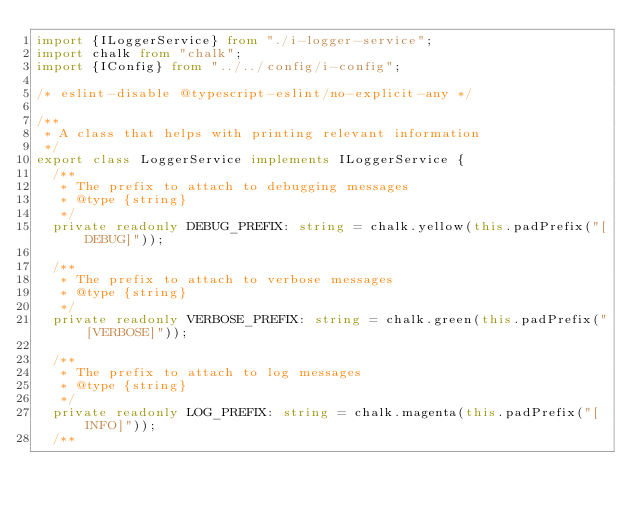<code> <loc_0><loc_0><loc_500><loc_500><_TypeScript_>import {ILoggerService} from "./i-logger-service";
import chalk from "chalk";
import {IConfig} from "../../config/i-config";

/* eslint-disable @typescript-eslint/no-explicit-any */

/**
 * A class that helps with printing relevant information
 */
export class LoggerService implements ILoggerService {
	/**
	 * The prefix to attach to debugging messages
	 * @type {string}
	 */
	private readonly DEBUG_PREFIX: string = chalk.yellow(this.padPrefix("[DEBUG]"));

	/**
	 * The prefix to attach to verbose messages
	 * @type {string}
	 */
	private readonly VERBOSE_PREFIX: string = chalk.green(this.padPrefix("[VERBOSE]"));

	/**
	 * The prefix to attach to log messages
	 * @type {string}
	 */
	private readonly LOG_PREFIX: string = chalk.magenta(this.padPrefix("[INFO]"));
	/**</code> 